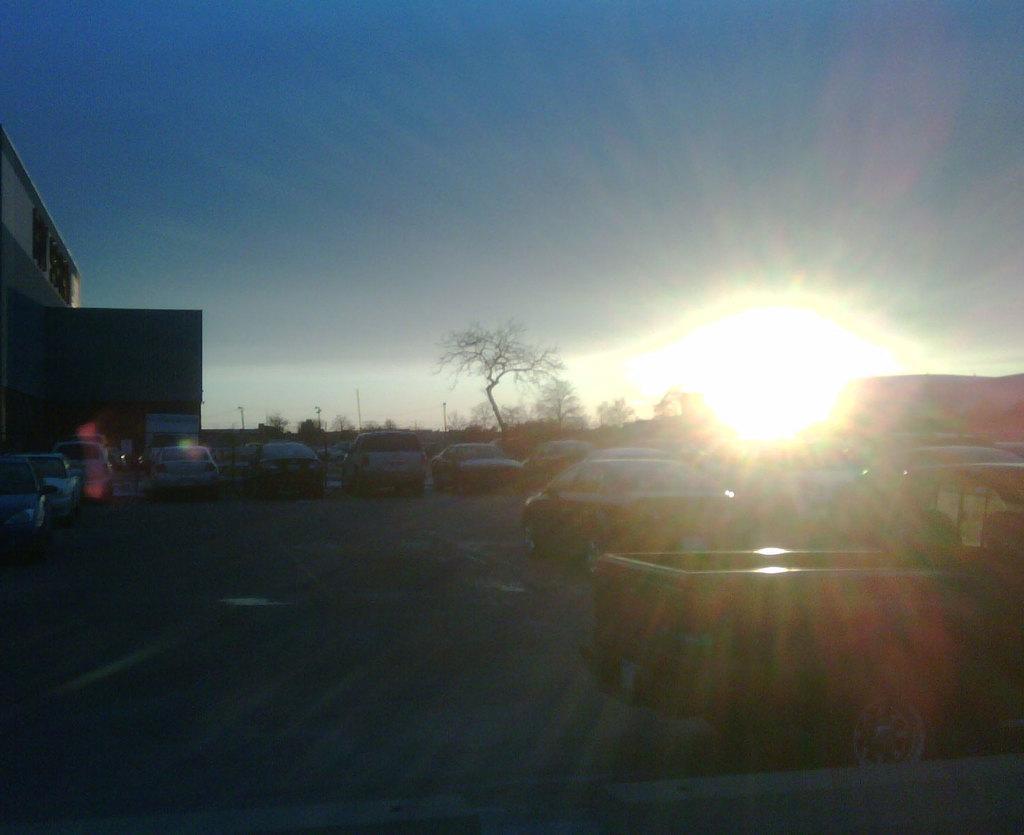How would you summarize this image in a sentence or two? In this image there is the sky towards the top of the image, there is the sun in the sky, there are trees, there is a building towards the left of the image, there is text on the building, there is ground towards the bottom of the image, there are cars on the ground, there is an object towards the right of the image. 